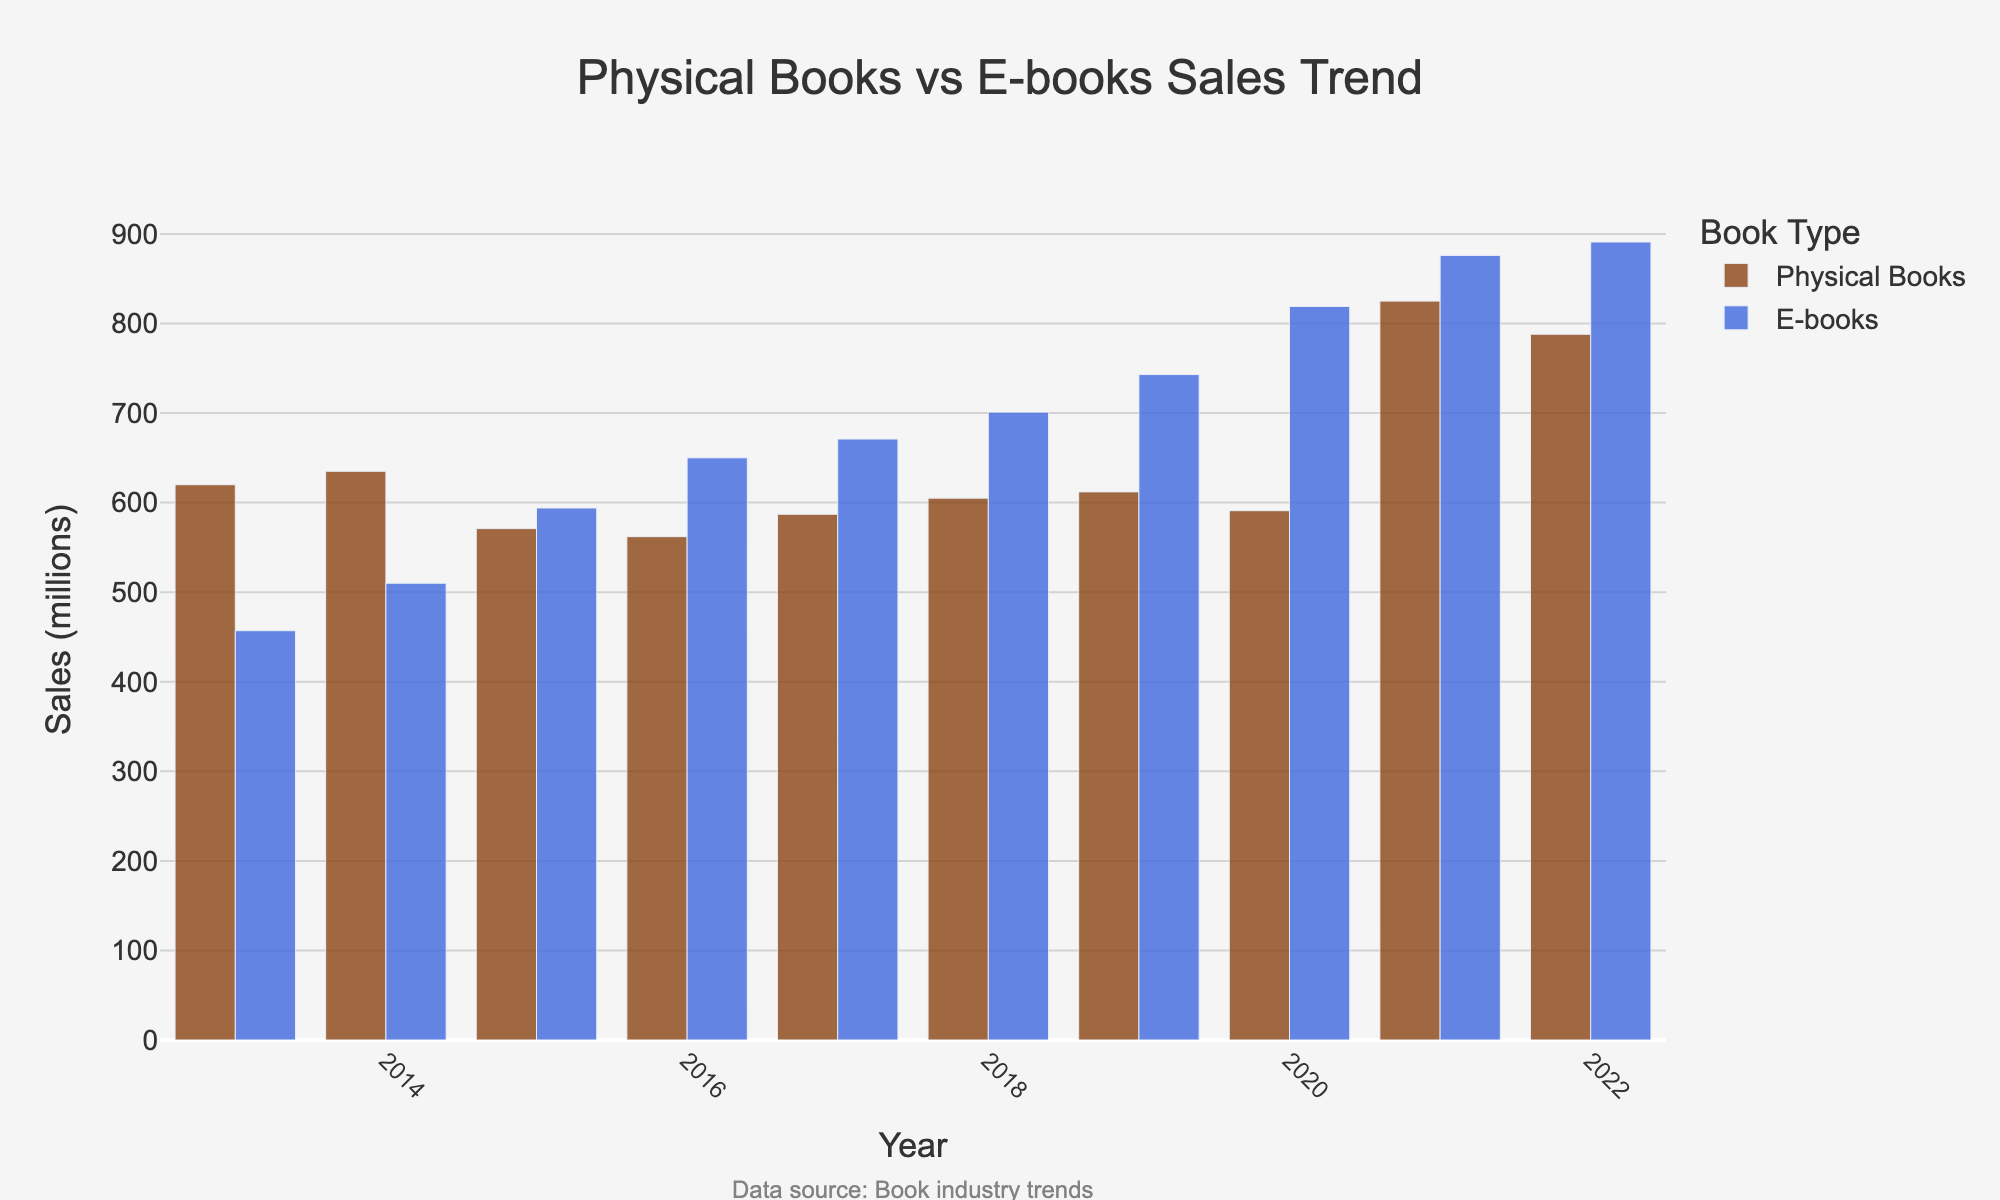What year did physical book sales peak? Look for the highest bar corresponding to physical book sales. It peaks in 2021.
Answer: 2021 In which year did e-book sales surpass physical book sales for the first time? Identify the first year where the e-book bar exceeds the physical book bar. This happens in 2015.
Answer: 2015 What is the difference in sales between physical books and e-books in 2021? Find the values for 2021: Physical books = 825 million, E-books = 876 million. Subtract physical book sales from e-book sales: 876 - 825 = 51 million.
Answer: 51 million Which book type had a larger increase in sales from 2014 to 2015? Calculate the increase for each book type: 
Physical books: 571 - 635 = -64 million (decrease)
E-books: 594 - 510 = 84 million (increase)
E-books had a larger increase.
Answer: E-books What is the average sales of physical books from 2018 to 2022? Find the values: 2018 (605), 2019 (612), 2020 (591), 2021 (825), 2022 (788). Sum them: 605 + 612 + 591 + 825 + 788 = 3421. Average: 3421 / 5 = 684.2 million.
Answer: 684.2 million How many times did physical book sales exceed 600 million? Identify the years and values where physical book sales are above 600 million: 2013 (620), 2014 (635), 2017 (587), 2018 (605), 2019 (612), 2021 (825), 2022 (788). Count these instances: 6 times.
Answer: 6 times Which year had the smallest difference between physical book sales and e-book sales? Calculate the difference for each year and compare them: 
2013: 620 - 457 = 163 million
2014: 635 - 510 = 125 million
2015: 571 - 594 = -23 million
2016: 562 - 650 = -88 million
2017: 587 - 671 = -84 million
2018: 605 - 701 = -96 million
2019: 612 - 743 = -131 million
2020: 591 - 819 = -228 million
2021: 825 - 876 = -51 million
2022: 788 - 891 = -103 million
The smallest difference is in 2015 with -23 million.
Answer: 2015 In what year did e-book sales grow the most compared to the previous year? Calculate the growth for each year and find the maximum: 
2014: 510 - 457 = 53 million
2015: 594 - 510 = 84 million
2016: 650 - 594 = 56 million
2017: 671 - 650 = 21 million
2018: 701 - 671 = 30 million
2019: 743 - 701 = 42 million
2020: 819 - 743 = 76 million
2021: 876 - 819 = 57 million
2022: 891 - 876 = 15 million
The largest growth was in 2015 with 84 million.
Answer: 2015 Which book type saw the larger overall sales increase from 2013 to 2022? Calculate the overall increase for each book type:
Physical books: 788 - 620 = 168 million
E-books: 891 - 457 = 434 million
E-books had a larger overall increase.
Answer: E-books 